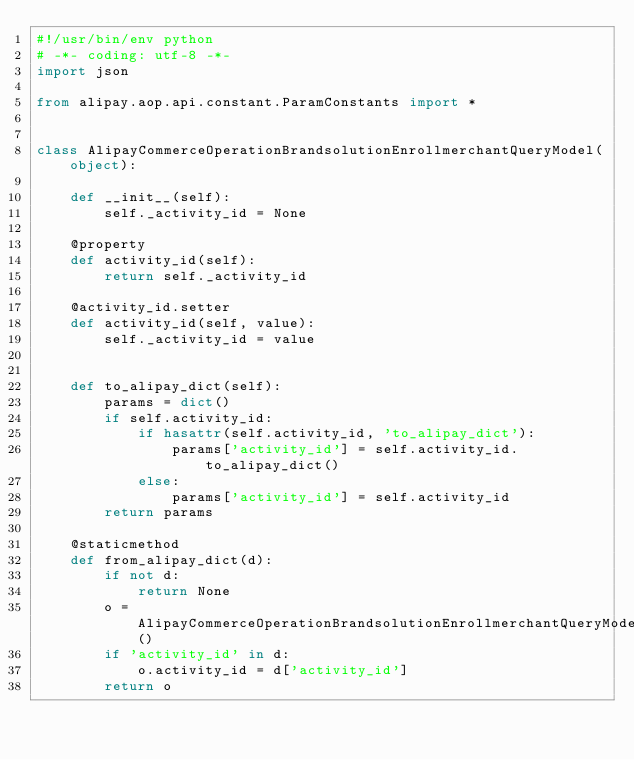Convert code to text. <code><loc_0><loc_0><loc_500><loc_500><_Python_>#!/usr/bin/env python
# -*- coding: utf-8 -*-
import json

from alipay.aop.api.constant.ParamConstants import *


class AlipayCommerceOperationBrandsolutionEnrollmerchantQueryModel(object):

    def __init__(self):
        self._activity_id = None

    @property
    def activity_id(self):
        return self._activity_id

    @activity_id.setter
    def activity_id(self, value):
        self._activity_id = value


    def to_alipay_dict(self):
        params = dict()
        if self.activity_id:
            if hasattr(self.activity_id, 'to_alipay_dict'):
                params['activity_id'] = self.activity_id.to_alipay_dict()
            else:
                params['activity_id'] = self.activity_id
        return params

    @staticmethod
    def from_alipay_dict(d):
        if not d:
            return None
        o = AlipayCommerceOperationBrandsolutionEnrollmerchantQueryModel()
        if 'activity_id' in d:
            o.activity_id = d['activity_id']
        return o


</code> 